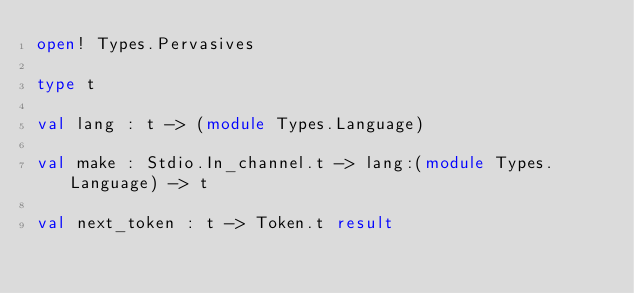Convert code to text. <code><loc_0><loc_0><loc_500><loc_500><_OCaml_>open! Types.Pervasives

type t

val lang : t -> (module Types.Language)

val make : Stdio.In_channel.t -> lang:(module Types.Language) -> t

val next_token : t -> Token.t result
</code> 